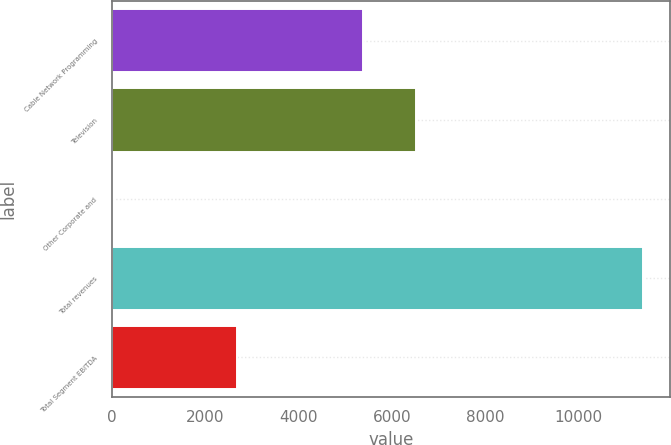<chart> <loc_0><loc_0><loc_500><loc_500><bar_chart><fcel>Cable Network Programming<fcel>Television<fcel>Other Corporate and<fcel>Total revenues<fcel>Total Segment EBITDA<nl><fcel>5381<fcel>6517<fcel>29<fcel>11389<fcel>2681<nl></chart> 